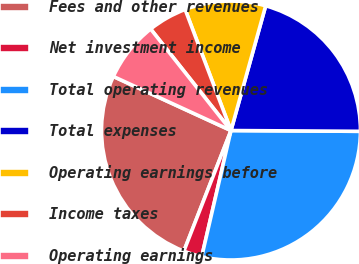<chart> <loc_0><loc_0><loc_500><loc_500><pie_chart><fcel>Fees and other revenues<fcel>Net investment income<fcel>Total operating revenues<fcel>Total expenses<fcel>Operating earnings before<fcel>Income taxes<fcel>Operating earnings<nl><fcel>25.93%<fcel>2.3%<fcel>28.53%<fcel>20.78%<fcel>10.08%<fcel>4.89%<fcel>7.49%<nl></chart> 